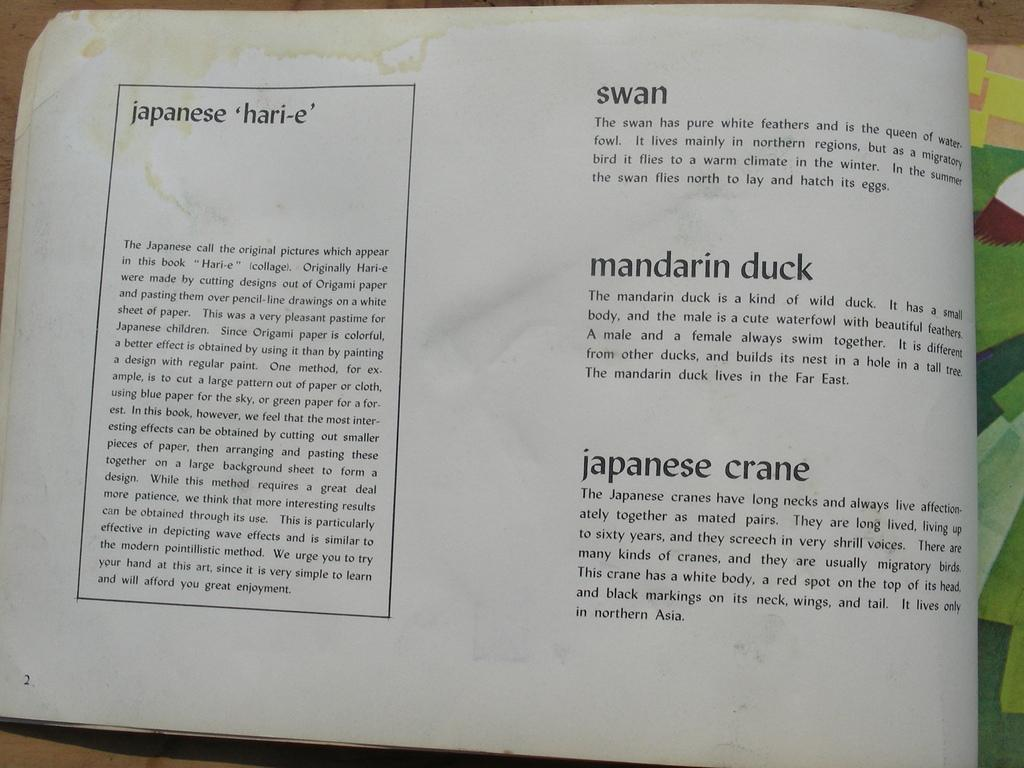<image>
Present a compact description of the photo's key features. A page from a book on Japanese Hari-e, a type of origami, there are three birds listed besde the main text, a swan, a mandarin duck and a Japanese crane. 